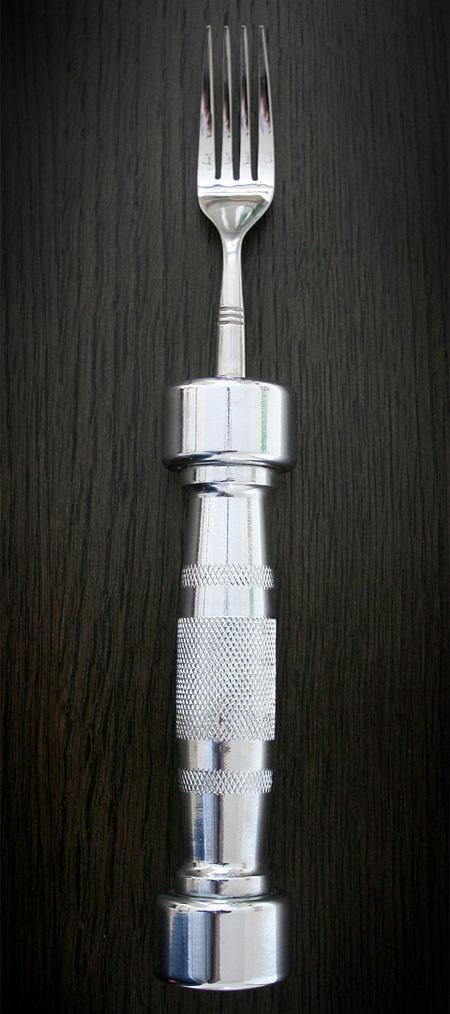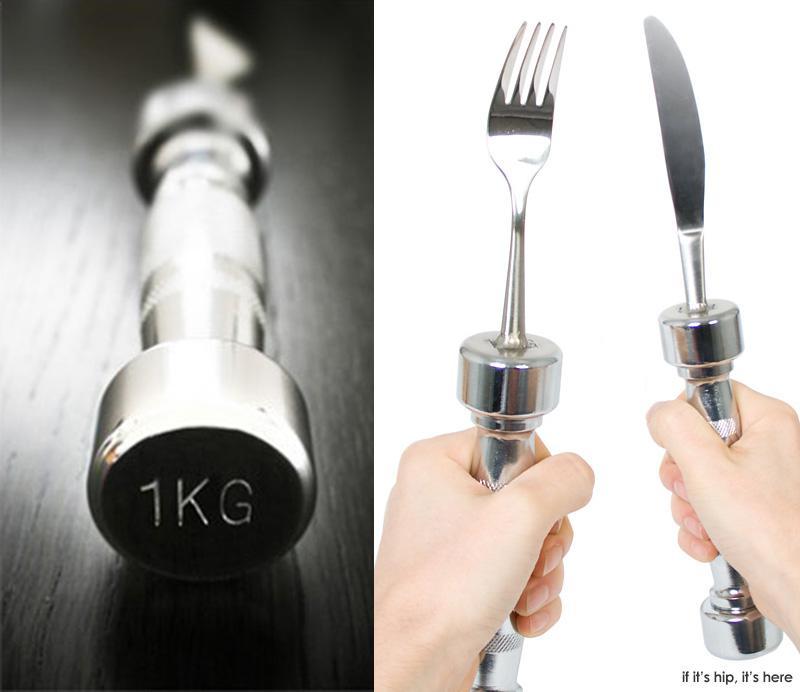The first image is the image on the left, the second image is the image on the right. Analyze the images presented: Is the assertion "One image shows a matched set of knife, fork, and spoon utensils standing on end." valid? Answer yes or no. No. The first image is the image on the left, the second image is the image on the right. Examine the images to the left and right. Is the description "Left image shows three utensils with barbell-shaped handles." accurate? Answer yes or no. No. 